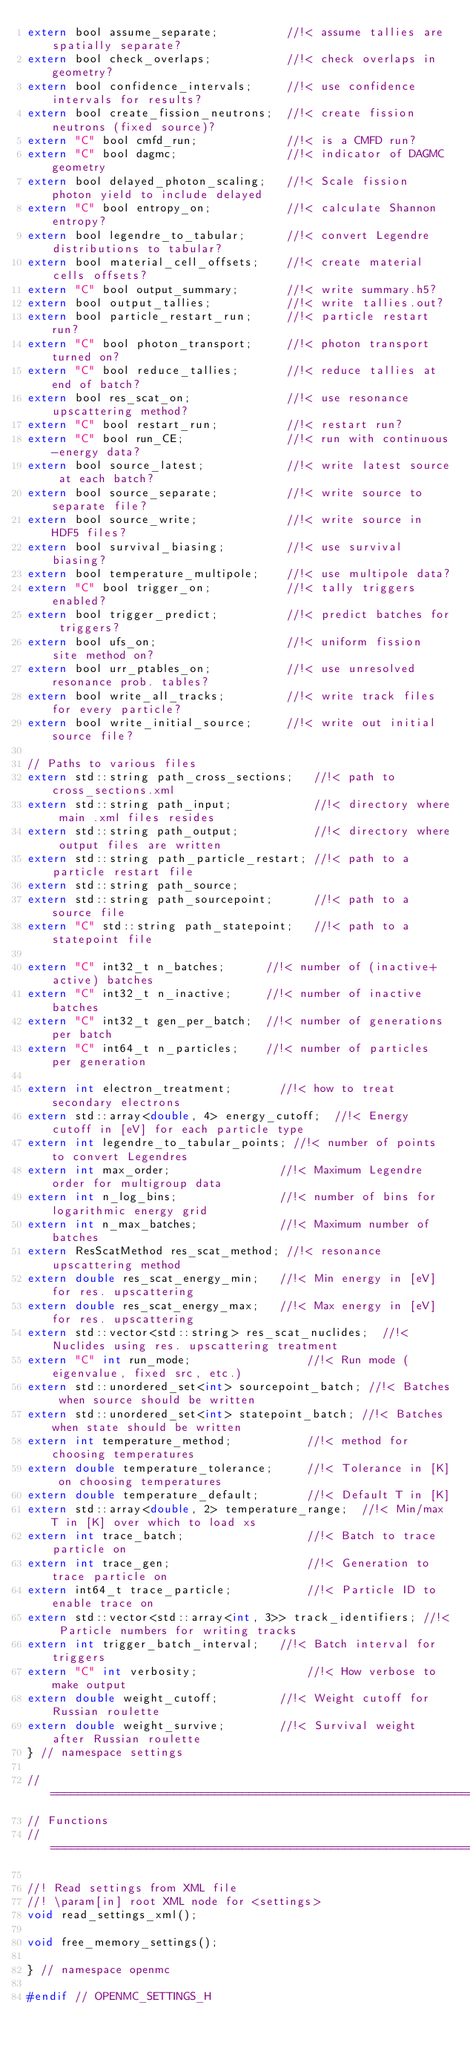Convert code to text. <code><loc_0><loc_0><loc_500><loc_500><_C_>extern bool assume_separate;          //!< assume tallies are spatially separate?
extern bool check_overlaps;           //!< check overlaps in geometry?
extern bool confidence_intervals;     //!< use confidence intervals for results?
extern bool create_fission_neutrons;  //!< create fission neutrons (fixed source)?
extern "C" bool cmfd_run;             //!< is a CMFD run?
extern "C" bool dagmc;                //!< indicator of DAGMC geometry
extern bool delayed_photon_scaling;   //!< Scale fission photon yield to include delayed
extern "C" bool entropy_on;           //!< calculate Shannon entropy?
extern bool legendre_to_tabular;      //!< convert Legendre distributions to tabular?
extern bool material_cell_offsets;    //!< create material cells offsets?
extern "C" bool output_summary;       //!< write summary.h5?
extern bool output_tallies;           //!< write tallies.out?
extern bool particle_restart_run;     //!< particle restart run?
extern "C" bool photon_transport;     //!< photon transport turned on?
extern "C" bool reduce_tallies;       //!< reduce tallies at end of batch?
extern bool res_scat_on;              //!< use resonance upscattering method?
extern "C" bool restart_run;          //!< restart run?
extern "C" bool run_CE;               //!< run with continuous-energy data?
extern bool source_latest;            //!< write latest source at each batch?
extern bool source_separate;          //!< write source to separate file?
extern bool source_write;             //!< write source in HDF5 files?
extern bool survival_biasing;         //!< use survival biasing?
extern bool temperature_multipole;    //!< use multipole data?
extern "C" bool trigger_on;           //!< tally triggers enabled?
extern bool trigger_predict;          //!< predict batches for triggers?
extern bool ufs_on;                   //!< uniform fission site method on?
extern bool urr_ptables_on;           //!< use unresolved resonance prob. tables?
extern bool write_all_tracks;         //!< write track files for every particle?
extern bool write_initial_source;     //!< write out initial source file?

// Paths to various files
extern std::string path_cross_sections;   //!< path to cross_sections.xml
extern std::string path_input;            //!< directory where main .xml files resides
extern std::string path_output;           //!< directory where output files are written
extern std::string path_particle_restart; //!< path to a particle restart file
extern std::string path_source;
extern std::string path_sourcepoint;      //!< path to a source file
extern "C" std::string path_statepoint;   //!< path to a statepoint file

extern "C" int32_t n_batches;      //!< number of (inactive+active) batches
extern "C" int32_t n_inactive;     //!< number of inactive batches
extern "C" int32_t gen_per_batch;  //!< number of generations per batch
extern "C" int64_t n_particles;    //!< number of particles per generation

extern int electron_treatment;       //!< how to treat secondary electrons
extern std::array<double, 4> energy_cutoff;  //!< Energy cutoff in [eV] for each particle type
extern int legendre_to_tabular_points; //!< number of points to convert Legendres
extern int max_order;                //!< Maximum Legendre order for multigroup data
extern int n_log_bins;               //!< number of bins for logarithmic energy grid
extern int n_max_batches;            //!< Maximum number of batches
extern ResScatMethod res_scat_method; //!< resonance upscattering method
extern double res_scat_energy_min;   //!< Min energy in [eV] for res. upscattering
extern double res_scat_energy_max;   //!< Max energy in [eV] for res. upscattering
extern std::vector<std::string> res_scat_nuclides;  //!< Nuclides using res. upscattering treatment
extern "C" int run_mode;                 //!< Run mode (eigenvalue, fixed src, etc.)
extern std::unordered_set<int> sourcepoint_batch; //!< Batches when source should be written
extern std::unordered_set<int> statepoint_batch; //!< Batches when state should be written
extern int temperature_method;           //!< method for choosing temperatures
extern double temperature_tolerance;     //!< Tolerance in [K] on choosing temperatures
extern double temperature_default;       //!< Default T in [K]
extern std::array<double, 2> temperature_range;  //!< Min/max T in [K] over which to load xs
extern int trace_batch;                  //!< Batch to trace particle on
extern int trace_gen;                    //!< Generation to trace particle on
extern int64_t trace_particle;           //!< Particle ID to enable trace on
extern std::vector<std::array<int, 3>> track_identifiers; //!< Particle numbers for writing tracks
extern int trigger_batch_interval;   //!< Batch interval for triggers
extern "C" int verbosity;                //!< How verbose to make output
extern double weight_cutoff;         //!< Weight cutoff for Russian roulette
extern double weight_survive;        //!< Survival weight after Russian roulette
} // namespace settings

//==============================================================================
// Functions
//==============================================================================

//! Read settings from XML file
//! \param[in] root XML node for <settings>
void read_settings_xml();

void free_memory_settings();

} // namespace openmc

#endif // OPENMC_SETTINGS_H
</code> 